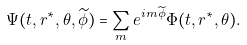Convert formula to latex. <formula><loc_0><loc_0><loc_500><loc_500>\Psi ( t , r ^ { * } , \theta , \widetilde { \phi } ) = \sum _ { m } e ^ { i m \widetilde { \phi } } \Phi ( t , r ^ { * } , \theta ) .</formula> 